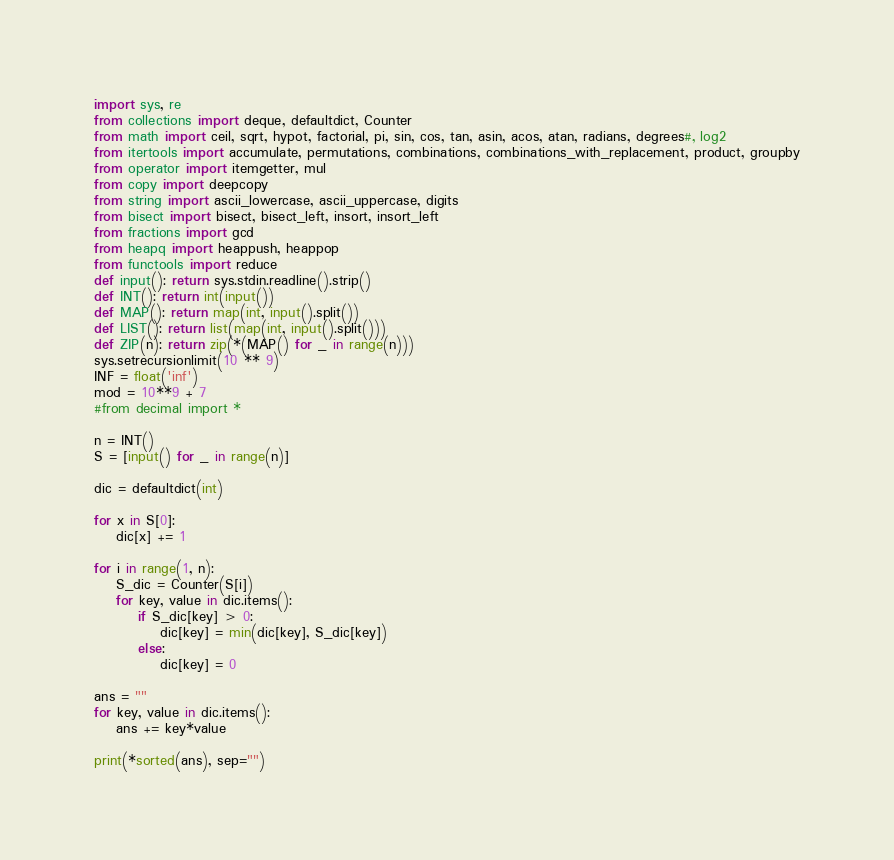<code> <loc_0><loc_0><loc_500><loc_500><_Python_>import sys, re
from collections import deque, defaultdict, Counter
from math import ceil, sqrt, hypot, factorial, pi, sin, cos, tan, asin, acos, atan, radians, degrees#, log2
from itertools import accumulate, permutations, combinations, combinations_with_replacement, product, groupby
from operator import itemgetter, mul
from copy import deepcopy
from string import ascii_lowercase, ascii_uppercase, digits
from bisect import bisect, bisect_left, insort, insort_left
from fractions import gcd
from heapq import heappush, heappop
from functools import reduce
def input(): return sys.stdin.readline().strip()
def INT(): return int(input())
def MAP(): return map(int, input().split())
def LIST(): return list(map(int, input().split()))
def ZIP(n): return zip(*(MAP() for _ in range(n)))
sys.setrecursionlimit(10 ** 9)
INF = float('inf')
mod = 10**9 + 7
#from decimal import *
 
n = INT()
S = [input() for _ in range(n)]

dic = defaultdict(int)

for x in S[0]:
	dic[x] += 1

for i in range(1, n):
	S_dic = Counter(S[i])
	for key, value in dic.items():
		if S_dic[key] > 0:
			dic[key] = min(dic[key], S_dic[key])
		else:
			dic[key] = 0
		
ans = ""
for key, value in dic.items():
	ans += key*value

print(*sorted(ans), sep="")
</code> 